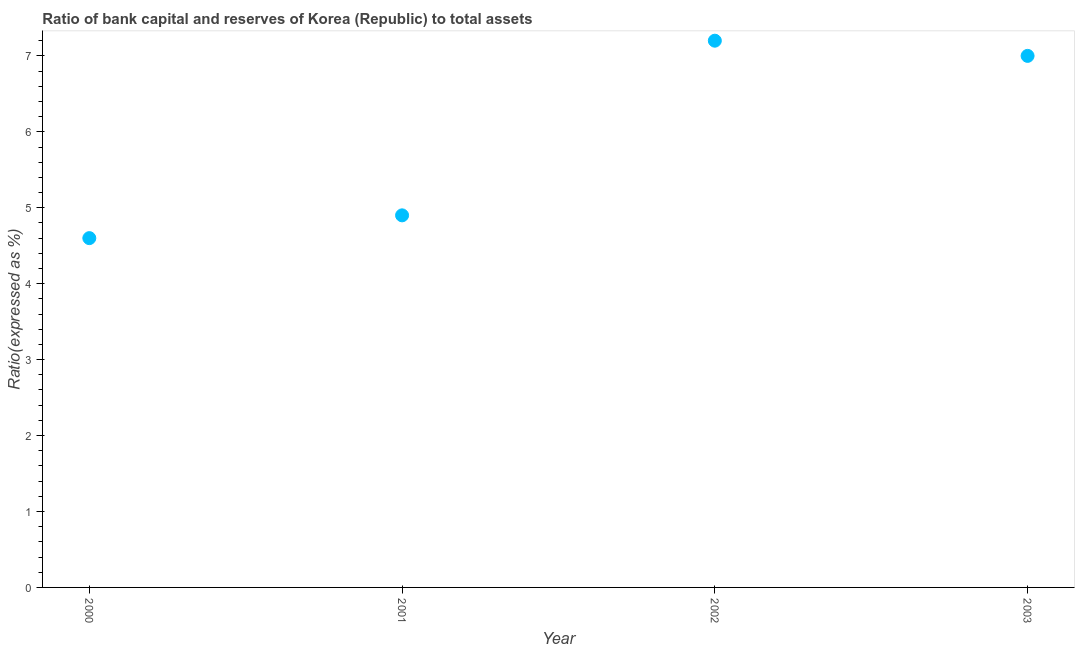Across all years, what is the maximum bank capital to assets ratio?
Keep it short and to the point. 7.2. Across all years, what is the minimum bank capital to assets ratio?
Provide a succinct answer. 4.6. In which year was the bank capital to assets ratio minimum?
Make the answer very short. 2000. What is the sum of the bank capital to assets ratio?
Keep it short and to the point. 23.7. What is the difference between the bank capital to assets ratio in 2002 and 2003?
Ensure brevity in your answer.  0.2. What is the average bank capital to assets ratio per year?
Your response must be concise. 5.92. What is the median bank capital to assets ratio?
Provide a short and direct response. 5.95. In how many years, is the bank capital to assets ratio greater than 2 %?
Your answer should be compact. 4. Do a majority of the years between 2001 and 2000 (inclusive) have bank capital to assets ratio greater than 0.6000000000000001 %?
Keep it short and to the point. No. What is the ratio of the bank capital to assets ratio in 2002 to that in 2003?
Offer a very short reply. 1.03. Is the bank capital to assets ratio in 2001 less than that in 2003?
Provide a succinct answer. Yes. Is the difference between the bank capital to assets ratio in 2000 and 2002 greater than the difference between any two years?
Your response must be concise. Yes. What is the difference between the highest and the second highest bank capital to assets ratio?
Make the answer very short. 0.2. What is the difference between the highest and the lowest bank capital to assets ratio?
Make the answer very short. 2.6. In how many years, is the bank capital to assets ratio greater than the average bank capital to assets ratio taken over all years?
Provide a short and direct response. 2. Does the bank capital to assets ratio monotonically increase over the years?
Provide a short and direct response. No. How many dotlines are there?
Provide a succinct answer. 1. What is the title of the graph?
Make the answer very short. Ratio of bank capital and reserves of Korea (Republic) to total assets. What is the label or title of the X-axis?
Give a very brief answer. Year. What is the label or title of the Y-axis?
Make the answer very short. Ratio(expressed as %). What is the Ratio(expressed as %) in 2003?
Keep it short and to the point. 7. What is the difference between the Ratio(expressed as %) in 2000 and 2001?
Your answer should be very brief. -0.3. What is the difference between the Ratio(expressed as %) in 2000 and 2002?
Give a very brief answer. -2.6. What is the difference between the Ratio(expressed as %) in 2001 and 2003?
Provide a short and direct response. -2.1. What is the ratio of the Ratio(expressed as %) in 2000 to that in 2001?
Make the answer very short. 0.94. What is the ratio of the Ratio(expressed as %) in 2000 to that in 2002?
Your answer should be very brief. 0.64. What is the ratio of the Ratio(expressed as %) in 2000 to that in 2003?
Keep it short and to the point. 0.66. What is the ratio of the Ratio(expressed as %) in 2001 to that in 2002?
Offer a terse response. 0.68. What is the ratio of the Ratio(expressed as %) in 2001 to that in 2003?
Offer a very short reply. 0.7. 